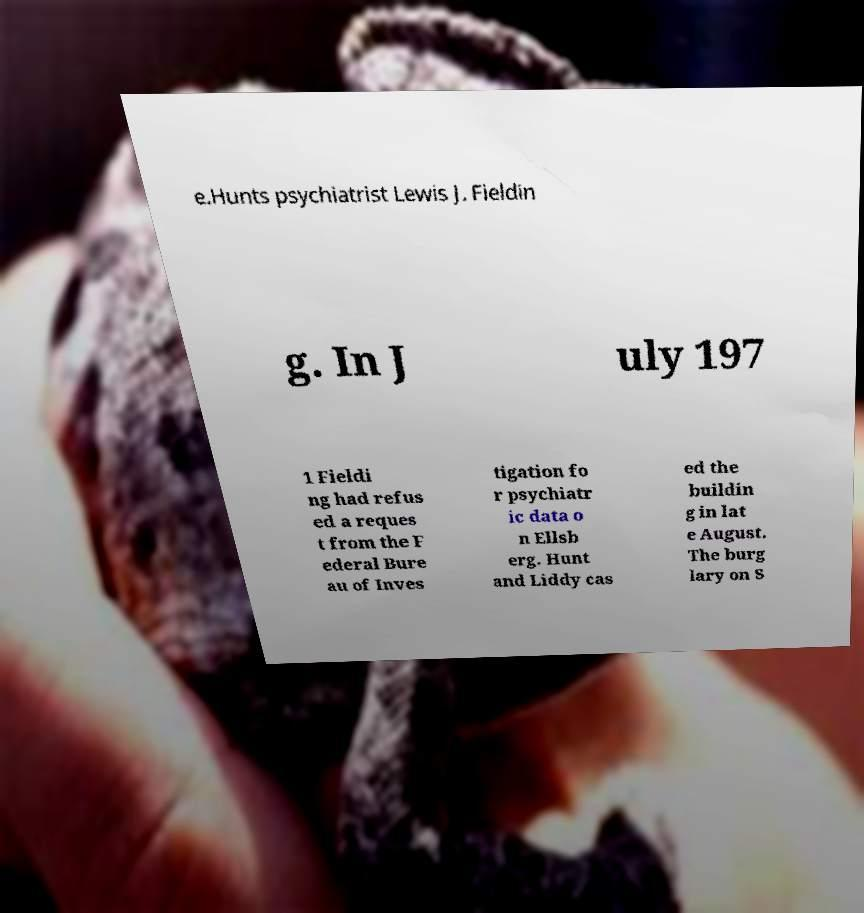I need the written content from this picture converted into text. Can you do that? e.Hunts psychiatrist Lewis J. Fieldin g. In J uly 197 1 Fieldi ng had refus ed a reques t from the F ederal Bure au of Inves tigation fo r psychiatr ic data o n Ellsb erg. Hunt and Liddy cas ed the buildin g in lat e August. The burg lary on S 